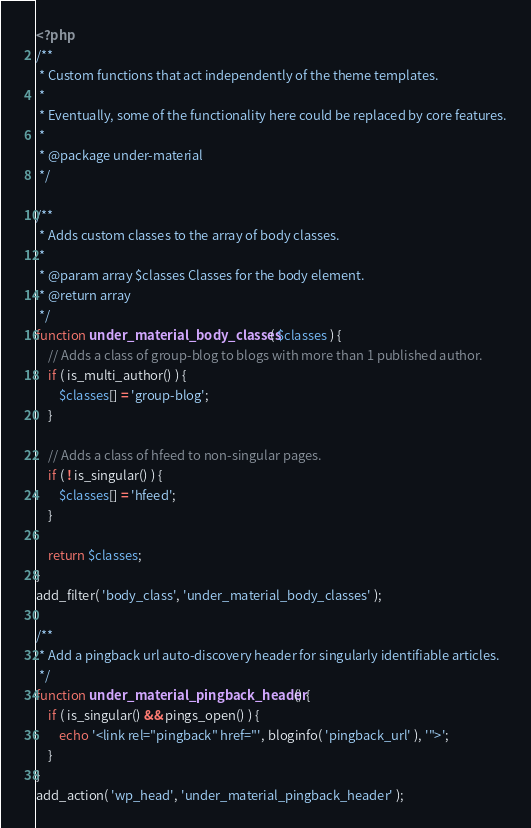Convert code to text. <code><loc_0><loc_0><loc_500><loc_500><_PHP_><?php
/**
 * Custom functions that act independently of the theme templates.
 *
 * Eventually, some of the functionality here could be replaced by core features.
 *
 * @package under-material
 */

/**
 * Adds custom classes to the array of body classes.
 *
 * @param array $classes Classes for the body element.
 * @return array
 */
function under_material_body_classes( $classes ) {
	// Adds a class of group-blog to blogs with more than 1 published author.
	if ( is_multi_author() ) {
		$classes[] = 'group-blog';
	}

	// Adds a class of hfeed to non-singular pages.
	if ( ! is_singular() ) {
		$classes[] = 'hfeed';
	}

	return $classes;
}
add_filter( 'body_class', 'under_material_body_classes' );

/**
 * Add a pingback url auto-discovery header for singularly identifiable articles.
 */
function under_material_pingback_header() {
	if ( is_singular() && pings_open() ) {
		echo '<link rel="pingback" href="', bloginfo( 'pingback_url' ), '">';
	}
}
add_action( 'wp_head', 'under_material_pingback_header' );
</code> 